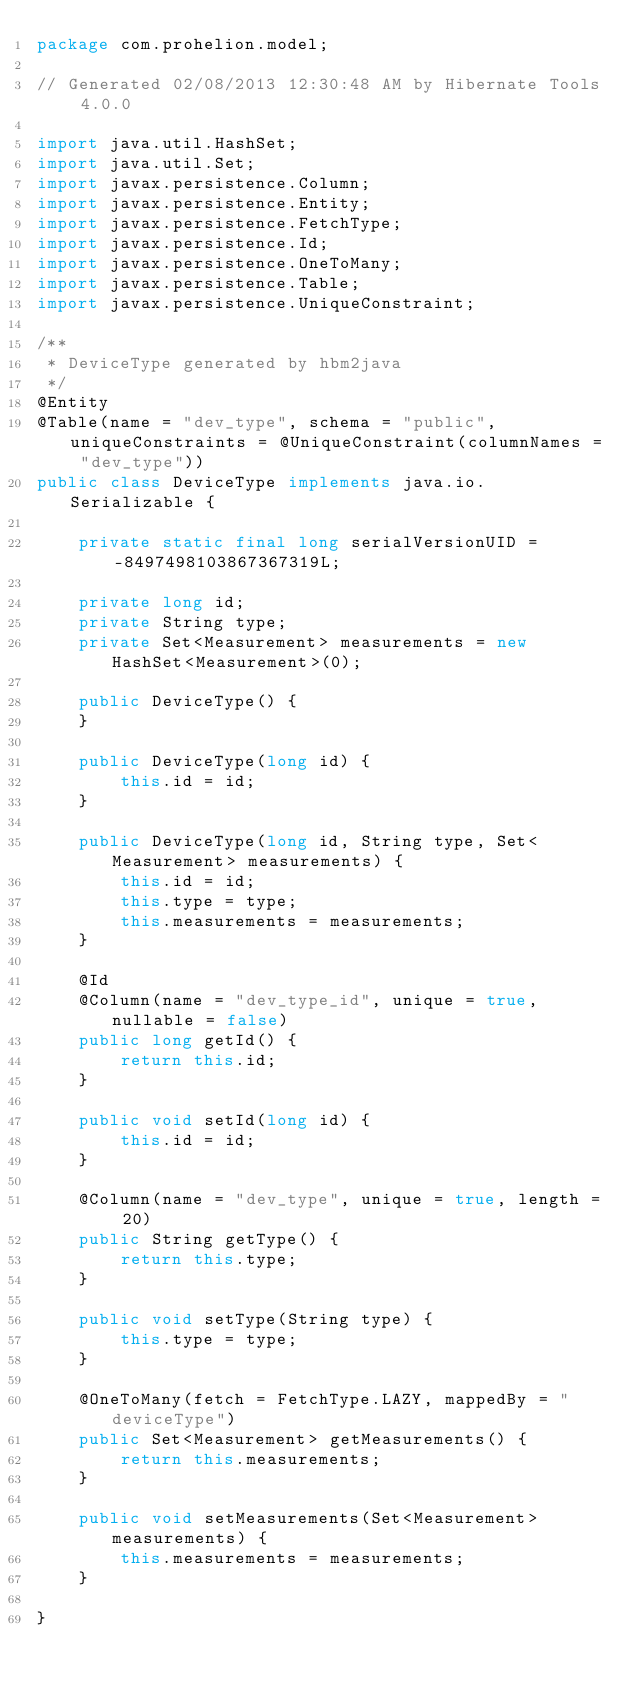<code> <loc_0><loc_0><loc_500><loc_500><_Java_>package com.prohelion.model;

// Generated 02/08/2013 12:30:48 AM by Hibernate Tools 4.0.0

import java.util.HashSet;
import java.util.Set;
import javax.persistence.Column;
import javax.persistence.Entity;
import javax.persistence.FetchType;
import javax.persistence.Id;
import javax.persistence.OneToMany;
import javax.persistence.Table;
import javax.persistence.UniqueConstraint;

/**
 * DeviceType generated by hbm2java
 */
@Entity
@Table(name = "dev_type", schema = "public", uniqueConstraints = @UniqueConstraint(columnNames = "dev_type"))
public class DeviceType implements java.io.Serializable {

	private static final long serialVersionUID = -8497498103867367319L;
	
	private long id;
    private String type;
    private Set<Measurement> measurements = new HashSet<Measurement>(0);

    public DeviceType() {
    }

    public DeviceType(long id) {
        this.id = id;
    }

    public DeviceType(long id, String type, Set<Measurement> measurements) {
        this.id = id;
        this.type = type;
        this.measurements = measurements;
    }

    @Id
    @Column(name = "dev_type_id", unique = true, nullable = false)
    public long getId() {
        return this.id;
    }

    public void setId(long id) {
        this.id = id;
    }

    @Column(name = "dev_type", unique = true, length = 20)
    public String getType() {
        return this.type;
    }

    public void setType(String type) {
        this.type = type;
    }

    @OneToMany(fetch = FetchType.LAZY, mappedBy = "deviceType")
    public Set<Measurement> getMeasurements() {
        return this.measurements;
    }

    public void setMeasurements(Set<Measurement> measurements) {
        this.measurements = measurements;
    }

}
</code> 